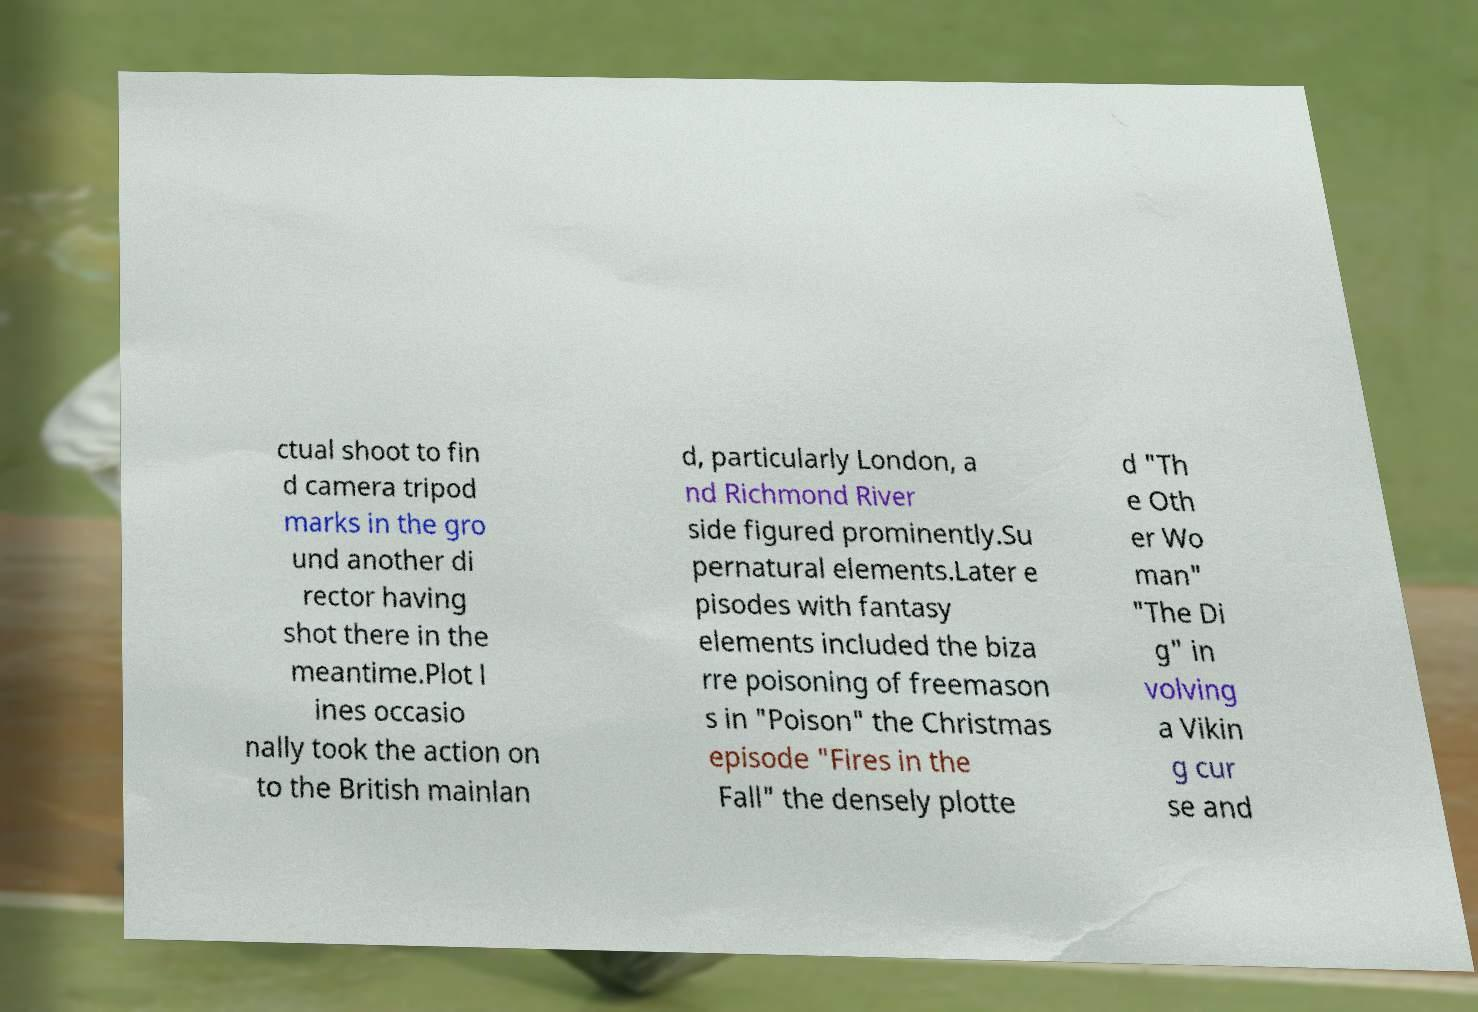I need the written content from this picture converted into text. Can you do that? ctual shoot to fin d camera tripod marks in the gro und another di rector having shot there in the meantime.Plot l ines occasio nally took the action on to the British mainlan d, particularly London, a nd Richmond River side figured prominently.Su pernatural elements.Later e pisodes with fantasy elements included the biza rre poisoning of freemason s in "Poison" the Christmas episode "Fires in the Fall" the densely plotte d "Th e Oth er Wo man" "The Di g" in volving a Vikin g cur se and 